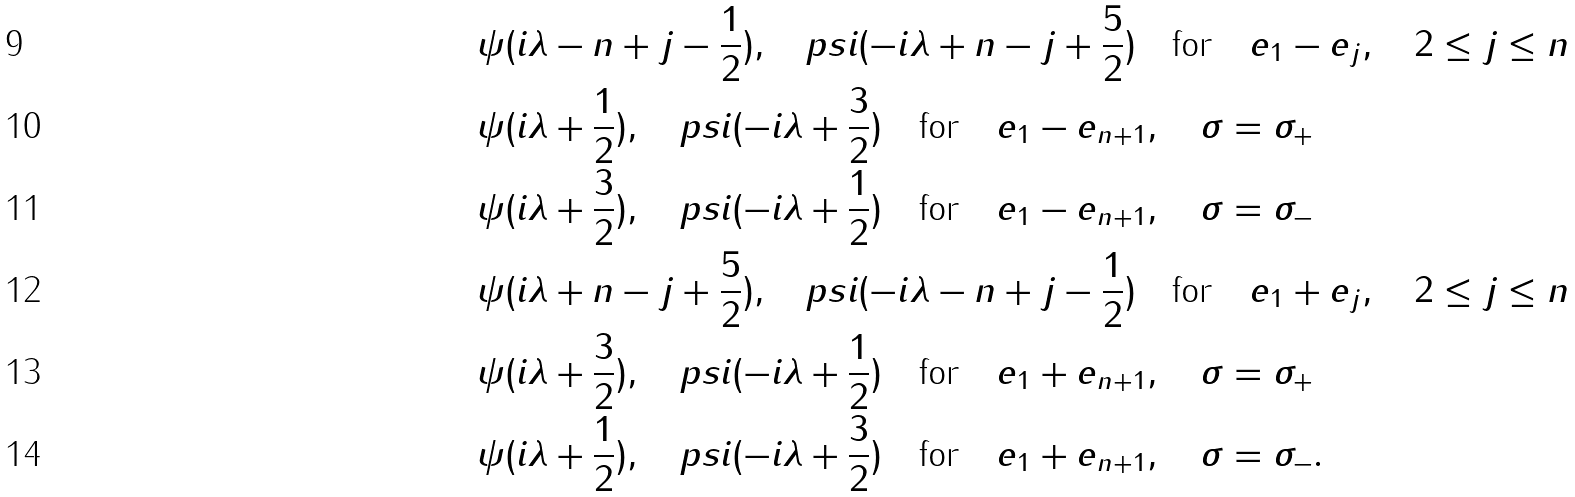Convert formula to latex. <formula><loc_0><loc_0><loc_500><loc_500>& \psi ( i \lambda - n + j - \frac { 1 } { 2 } ) , \quad p s i ( - i \lambda + n - j + \frac { 5 } { 2 } ) \quad \text {for} \quad e _ { 1 } - e _ { j } , \quad 2 \leq j \leq n \\ & \psi ( i \lambda + \frac { 1 } { 2 } ) , \quad p s i ( - i \lambda + \frac { 3 } { 2 } ) \quad \text {for} \quad e _ { 1 } - e _ { n + 1 } , \quad \sigma = \sigma _ { + } \\ & \psi ( i \lambda + \frac { 3 } { 2 } ) , \quad p s i ( - i \lambda + \frac { 1 } { 2 } ) \quad \text {for} \quad e _ { 1 } - e _ { n + 1 } , \quad \sigma = \sigma _ { - } \\ & \psi ( i \lambda + n - j + \frac { 5 } { 2 } ) , \quad p s i ( - i \lambda - n + j - \frac { 1 } { 2 } ) \quad \text {for} \quad e _ { 1 } + e _ { j } , \quad 2 \leq j \leq n \\ & \psi ( i \lambda + \frac { 3 } { 2 } ) , \quad p s i ( - i \lambda + \frac { 1 } { 2 } ) \quad \text {for} \quad e _ { 1 } + e _ { n + 1 } , \quad \sigma = \sigma _ { + } \\ & \psi ( i \lambda + \frac { 1 } { 2 } ) , \quad p s i ( - i \lambda + \frac { 3 } { 2 } ) \quad \text {for} \quad e _ { 1 } + e _ { n + 1 } , \quad \sigma = \sigma _ { - } .</formula> 